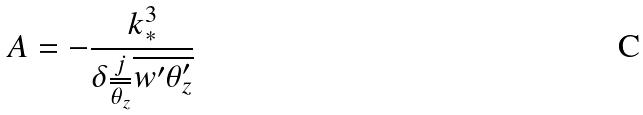Convert formula to latex. <formula><loc_0><loc_0><loc_500><loc_500>A = - \frac { k _ { * } ^ { 3 } } { \delta \frac { j } { \overline { \theta _ { z } } } \overline { w ^ { \prime } \theta _ { z } ^ { \prime } } }</formula> 